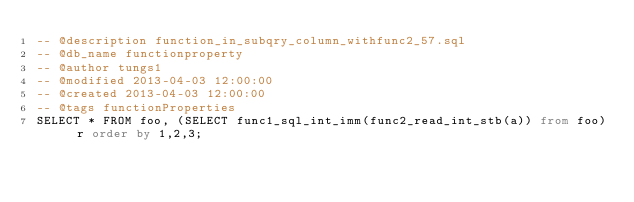Convert code to text. <code><loc_0><loc_0><loc_500><loc_500><_SQL_>-- @description function_in_subqry_column_withfunc2_57.sql
-- @db_name functionproperty
-- @author tungs1
-- @modified 2013-04-03 12:00:00
-- @created 2013-04-03 12:00:00
-- @tags functionProperties 
SELECT * FROM foo, (SELECT func1_sql_int_imm(func2_read_int_stb(a)) from foo) r order by 1,2,3; 
</code> 